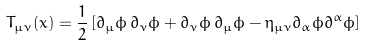<formula> <loc_0><loc_0><loc_500><loc_500>T _ { \mu \nu } ( x ) = \frac { 1 } { 2 } \left [ \partial _ { \mu } \phi \, \partial _ { \nu } \phi + \partial _ { \nu } \phi \, \partial _ { \mu } \phi - \eta _ { \mu \nu } \partial _ { \alpha } \phi \partial ^ { \alpha } \phi \right ]</formula> 